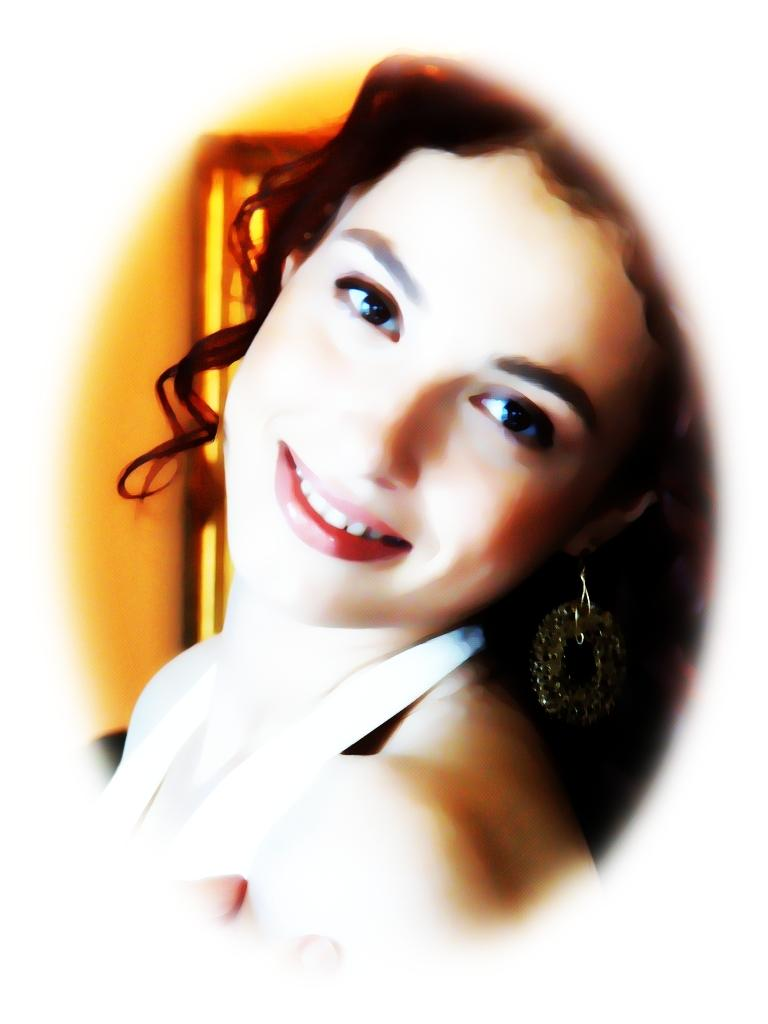Who is present in the image? There is a woman in the image. Where was the image likely taken? The image appears to be taken in a room. What type of celery is the woman holding in the image? There is no celery present in the image. How many hands does the woman have in the image? The number of hands the woman has cannot be determined from the image, as only one hand is visible. 